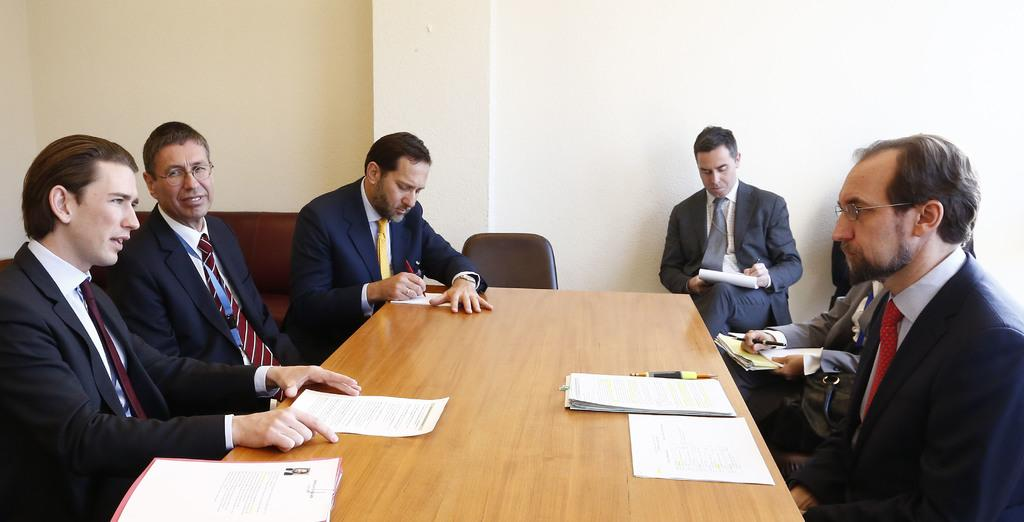How many people are sitting around the table in the image? There are six members sitting around the table. What are the members sitting on? The members are sitting in chairs. What can be seen on the table besides the chairs? There are papers on the table and a pen is placed on the table. What is visible in the background of the image? There is a wall in the background. What type of toe is visible in the image? There are no toes visible in the image; it features people sitting around a table. What idea is being discussed by the members in the image? The image does not provide any information about the topic of discussion among the members. 